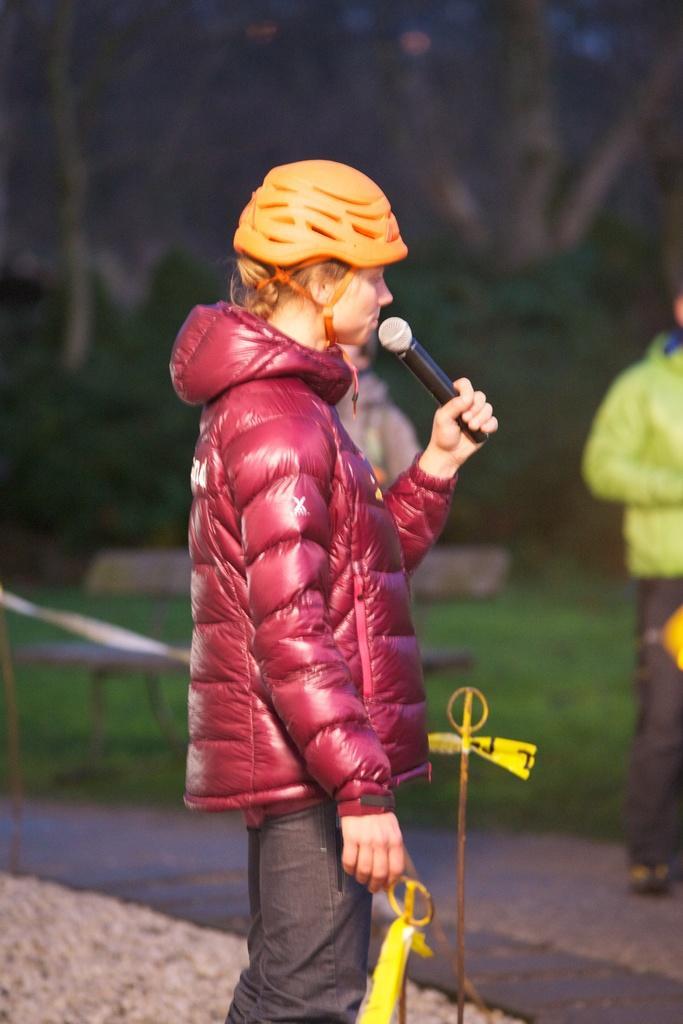How would you summarize this image in a sentence or two? Background portion of the picture is blurry and we can see green grass, branches. Plants are visible. In this picture we can see the people, caution tape and the poles. We can see a person wearing a jacket, helmet and holding a mike in the hand. At the bottom portion of the picture we can see the road. 